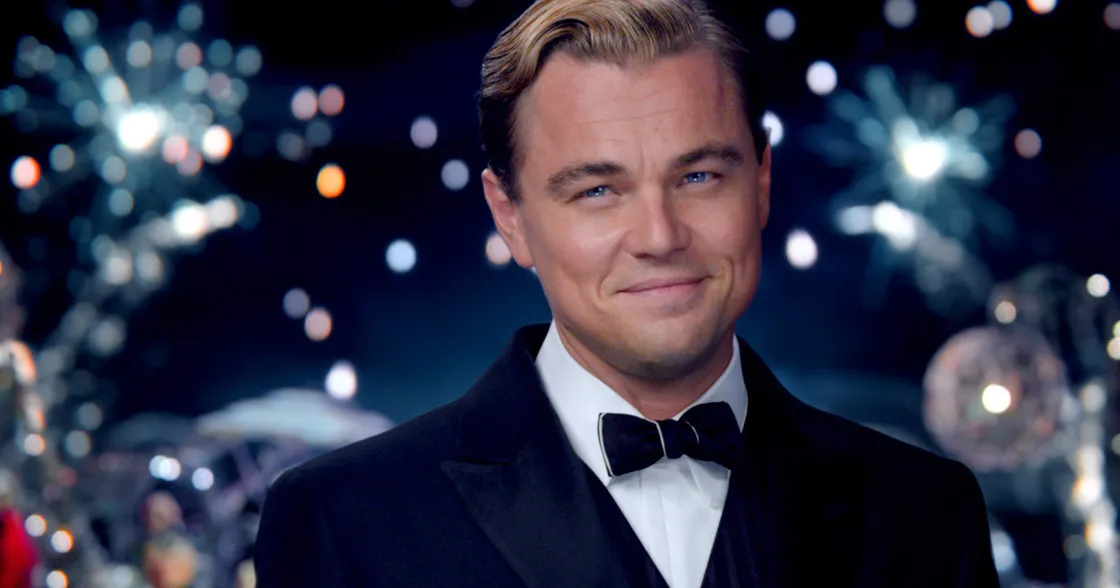Can you describe the atmosphere in the image in greater detail? The atmosphere in the image is exuberant and celebratory, characterized by the dazzling display of fireworks and an array of colorful lights that illuminate the night sky. The background seems to be teeming with activity, perhaps reflecting a lively party or festival. It exudes a sense of grandeur and luxury, enhanced by the character's sophisticated attire that matches the opulent setting. The overall mood is one of festivity and elegance, hinting at a moment of joy and celebration amid a backdrop of glamour and sophistication. What kind of event do you think is taking place here? This image likely depicts a lavish high-society event, such as a grand gala, a masquerade ball, or an extravagant New Year's Eve celebration. The fireworks and vibrant lights suggest significant festivities, and the character’s formal attire indicates that it is an exclusive event where guests dress in their finest clothing. The atmosphere is one of opulence and glamour, designed to impress and entertain attendees who enjoy the finer aspects of life. 